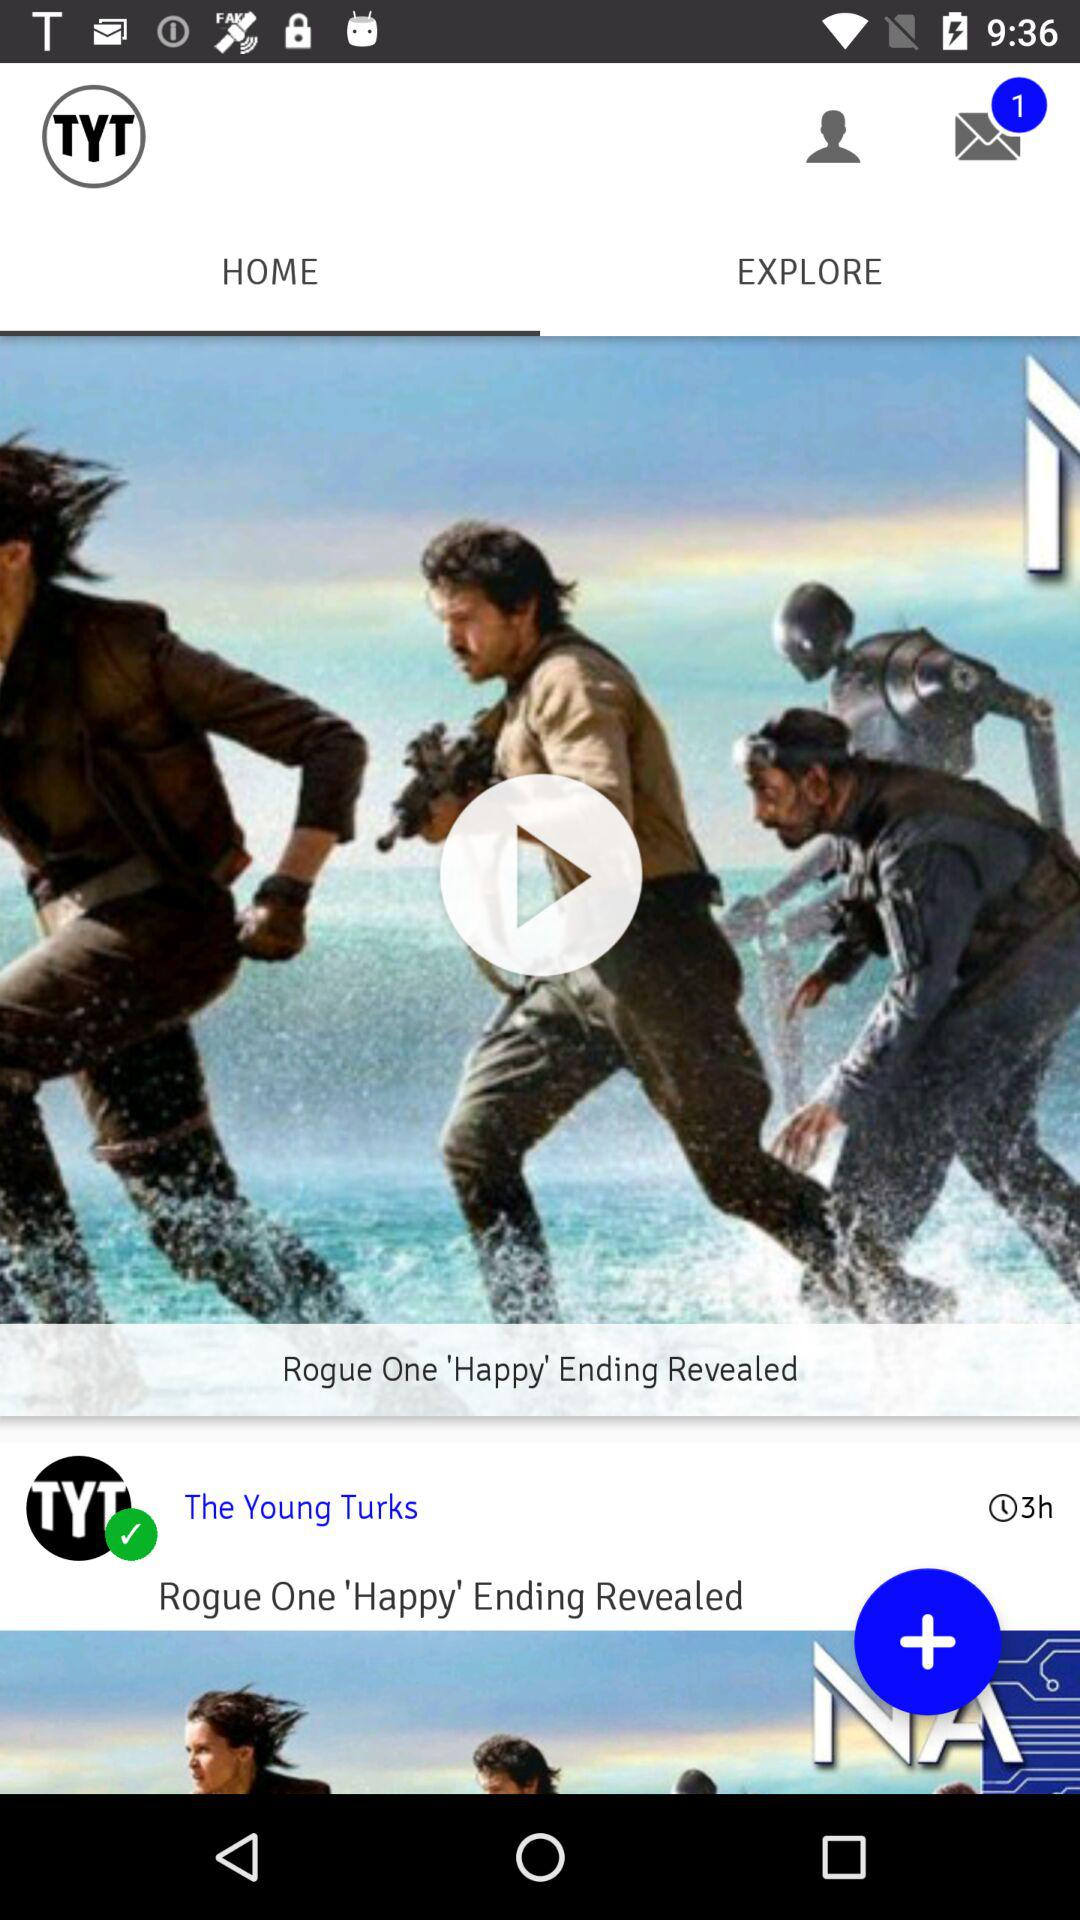How many hours ago did "The Young Turks" share the post? It was shared 3 hours ago. 